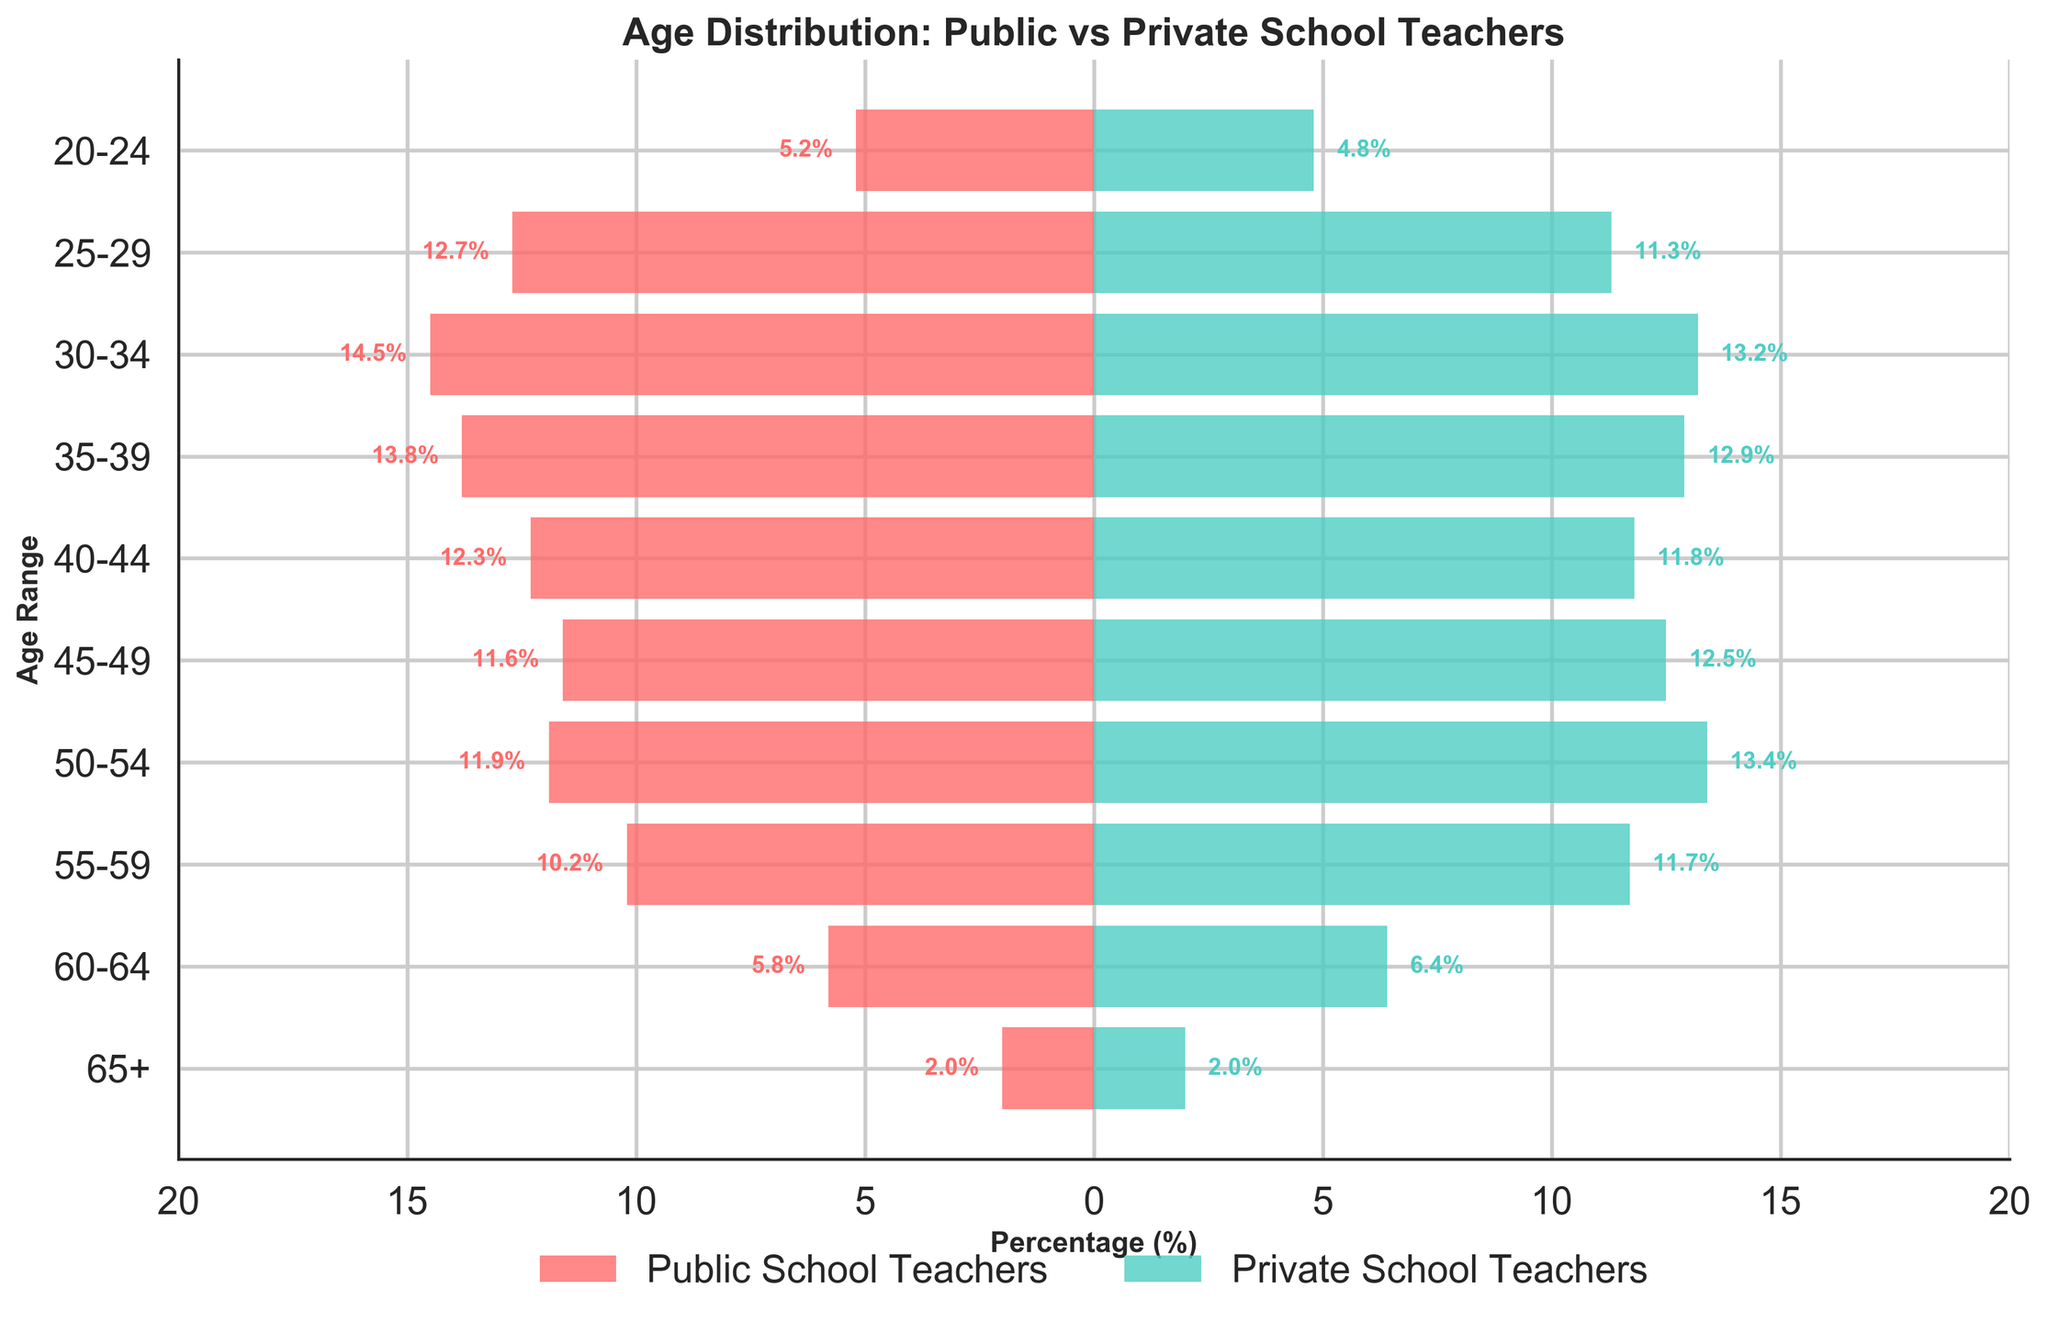What is the title of the figure? The title of the figure is displayed at the top, indicating the main topic or focus of the visual representation: 'Age Distribution: Public vs Private School Teachers'.
Answer: 'Age Distribution: Public vs Private School Teachers' What is the percentage of public school teachers in the age range 30-34? The percentage value is located on the horizontal bar corresponding to the "30-34" age range on the left side of the figure, indicated in red (-14.5%).
Answer: 14.5% How many distinct age ranges are displayed in the figure? By counting the labeled horizontal bars, we can see that there are ten distinct age ranges from "20-24" to "65+".
Answer: 10 Which age group has a higher percentage of private school teachers compared to public school teachers? By comparing the bars, the "45-49", "50-54", and "60-64" age ranges show higher percentages for private school teachers (12.5%, 13.4%, and 6.4%) than for public school teachers (11.6%, 11.9%, and 5.8%).
Answer: "45-49", "50-54", "60-64" Are there any age ranges where the percentages of public and private school teachers are equal? Checking each age range, the "65+" category shows equal percentages for both public and private school teachers at 2.0%.
Answer: "65+" In which age range do public school teachers see their highest percentage? By examining the longest red bar on the left side of the figure, the age range "30-34" shows the highest percentage of public school teachers with 14.5%.
Answer: 30-34 What is the median age range for private school teachers based on the visual pyramid? To find the median, we need to locate the middle data point when the percentages are arranged in order: Private school teachers are from age ranges "20-24", "25-29", "30-34", "35-39", "40-44", "45-49", "50-54", "55-59", "60-64", "65+". The middle is between "40-44" and "45-49", represented by the fourth and fifth ranges.
Answer: "40-44" and "45-49" Which age range has the smallest percentage difference between public and private school teachers? The difference between percentages can be observed by noting the gaps: "55-59" shows the smallest difference (10.2% public vs. 11.7% private), resulting in a 1.5% difference.
Answer: 55-59 What is the combined percentage of public and private school teachers in the "20-24" age range? By summing up the percentages of public school teachers (5.2%) and private school teachers (4.8%) in the "20-24" range, we get a total of 10%.
Answer: 10% Which age group has more public school teachers compared to private school teachers by at least 1%? By comparing each age range, those with a 1% difference include "30-34" (1.3% more public than private), "35-39" (0.9%), and "40-44" (0.5%). Only "30-34" meets this criterion.
Answer: 30-34 